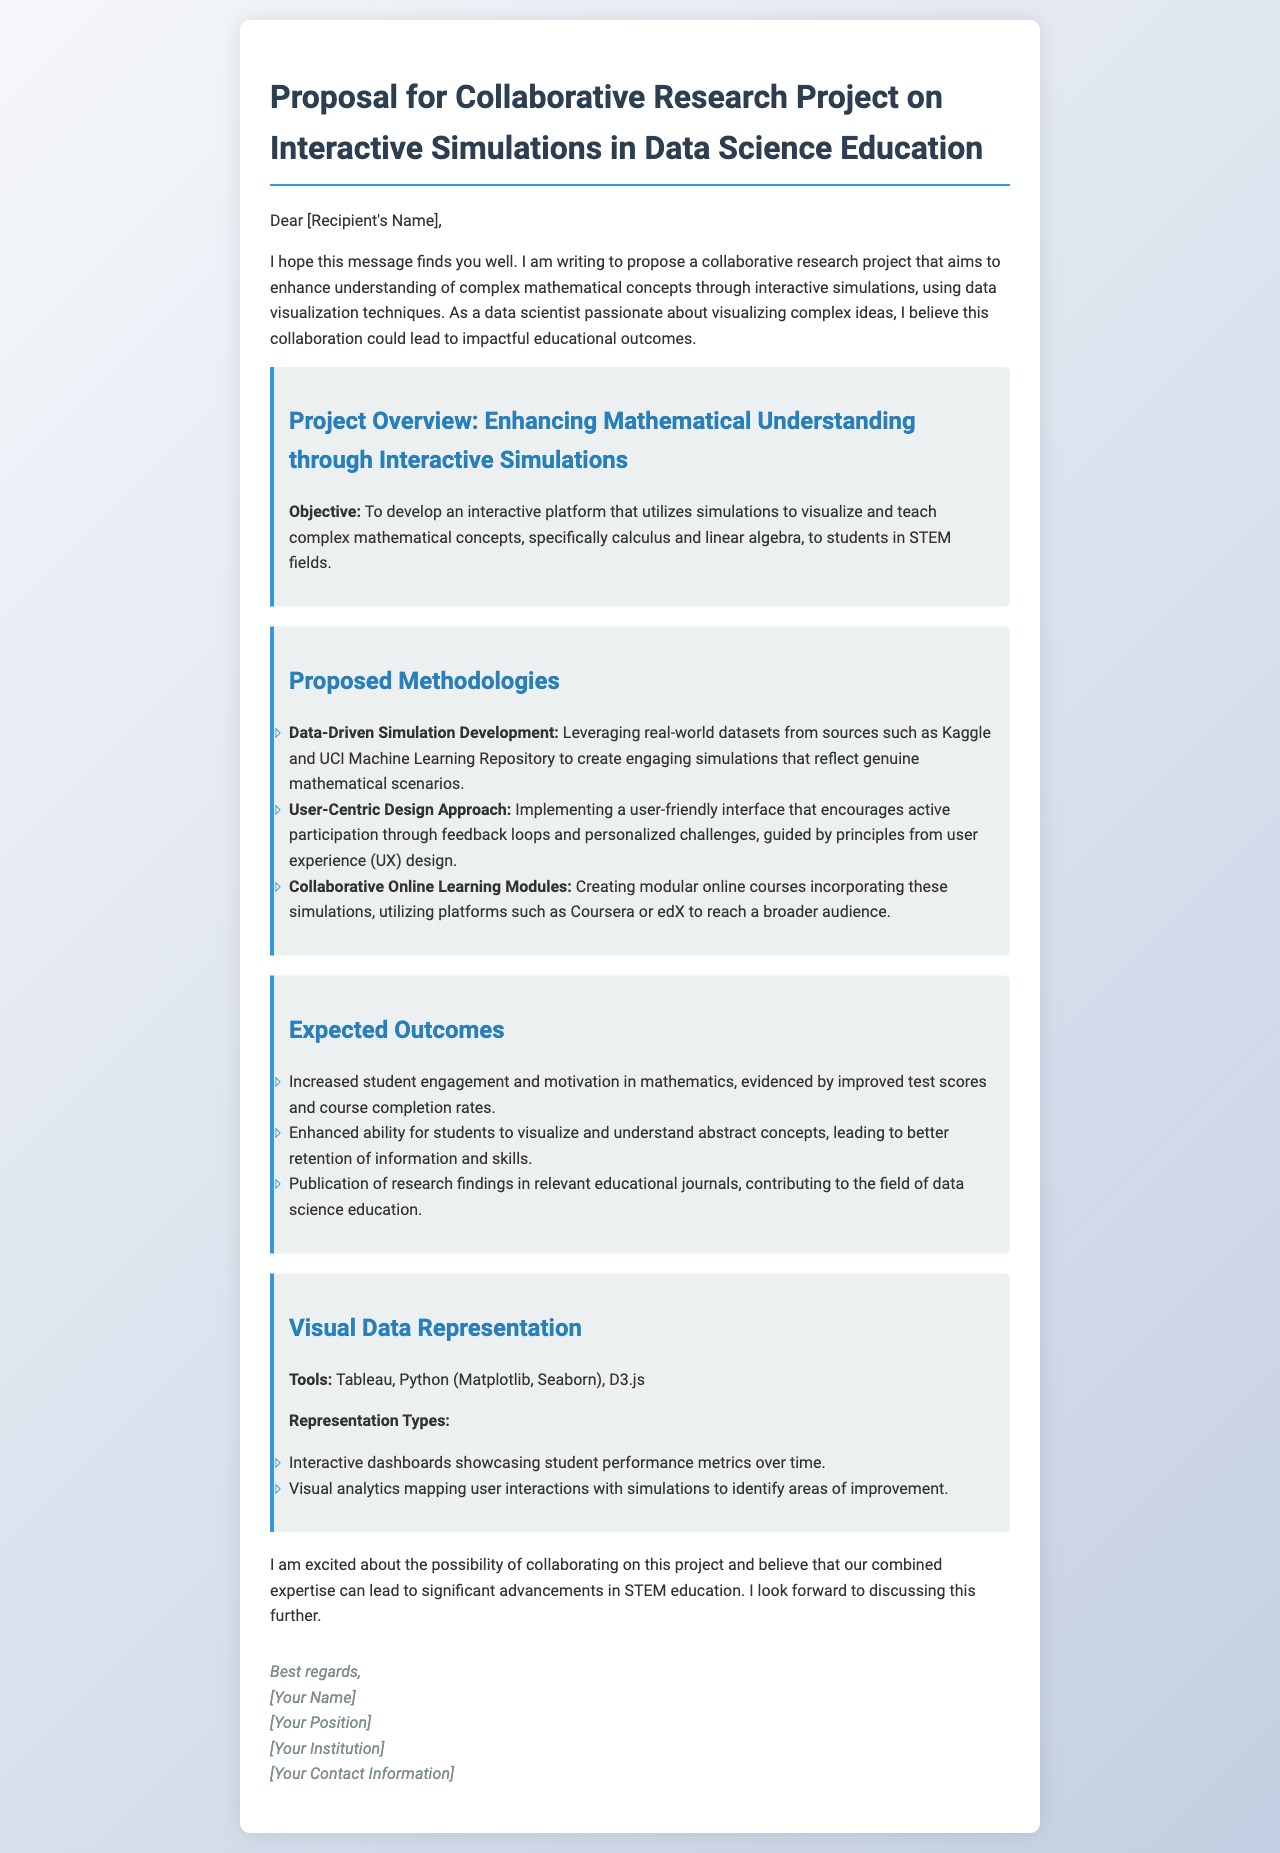What is the main objective of the project? The main objective is to develop an interactive platform that utilizes simulations to teach complex mathematical concepts to students in STEM fields.
Answer: To develop an interactive platform that utilizes simulations to teach complex mathematical concepts, specifically calculus and linear algebra, to students in STEM fields How many proposed methodologies are mentioned? The document lists three proposed methodologies, which include data-driven simulation development, user-centric design approach, and collaborative online learning modules.
Answer: Three What tools are suggested for visual data representation? The document specifies Tableau, Python (Matplotlib, Seaborn), and D3.js as the tools for visual data representation.
Answer: Tableau, Python (Matplotlib, Seaborn), D3.js What is one expected outcome of the research project? An expected outcome includes increased student engagement and motivation in mathematics, which can be measured by improved test scores and course completion rates.
Answer: Increased student engagement and motivation in mathematics What type of design approach will be implemented? The design approach mentioned emphasizes a user-friendly interface that encourages active participation through feedback loops and personalized challenges.
Answer: User-Centric Design Approach What will the research findings contribute to? The research findings are expected to contribute to the field of data science education through publication in relevant educational journals.
Answer: The field of data science education 